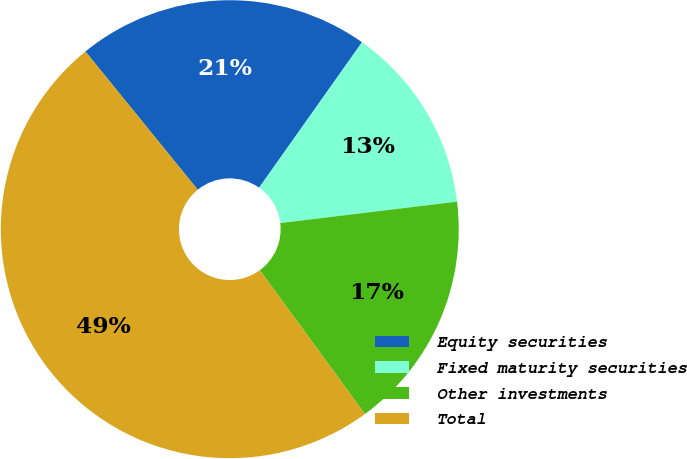Convert chart to OTSL. <chart><loc_0><loc_0><loc_500><loc_500><pie_chart><fcel>Equity securities<fcel>Fixed maturity securities<fcel>Other investments<fcel>Total<nl><fcel>20.66%<fcel>13.28%<fcel>16.87%<fcel>49.19%<nl></chart> 